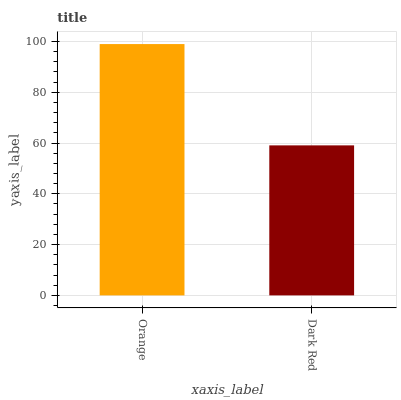Is Dark Red the minimum?
Answer yes or no. Yes. Is Orange the maximum?
Answer yes or no. Yes. Is Dark Red the maximum?
Answer yes or no. No. Is Orange greater than Dark Red?
Answer yes or no. Yes. Is Dark Red less than Orange?
Answer yes or no. Yes. Is Dark Red greater than Orange?
Answer yes or no. No. Is Orange less than Dark Red?
Answer yes or no. No. Is Orange the high median?
Answer yes or no. Yes. Is Dark Red the low median?
Answer yes or no. Yes. Is Dark Red the high median?
Answer yes or no. No. Is Orange the low median?
Answer yes or no. No. 